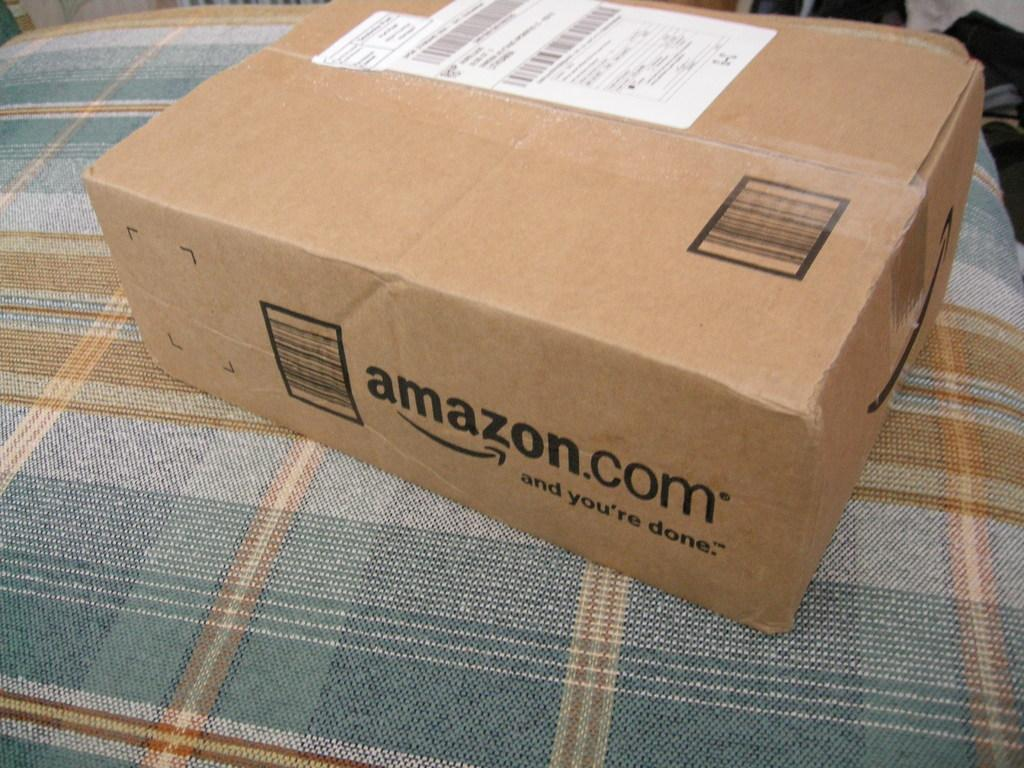<image>
Create a compact narrative representing the image presented. A package from Amazon.com placed on a bed cover. 